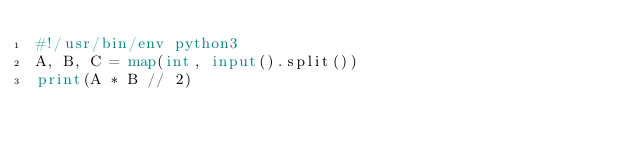<code> <loc_0><loc_0><loc_500><loc_500><_Python_>#!/usr/bin/env python3
A, B, C = map(int, input().split())
print(A * B // 2)
</code> 